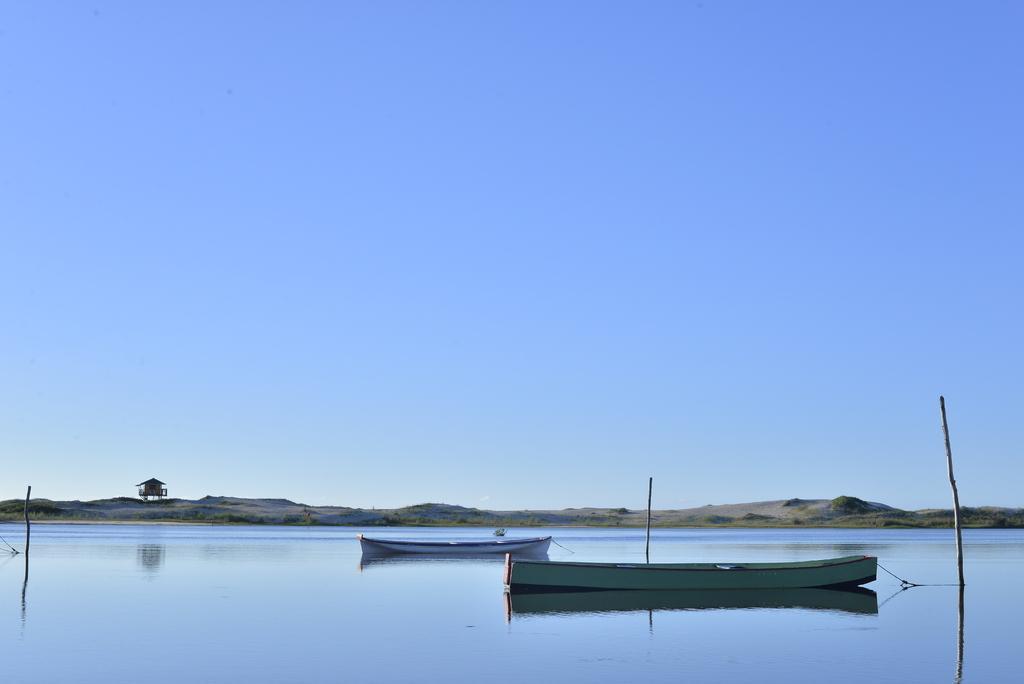Please provide a concise description of this image. In this picture we can see water at the bottom, there are two boats and three sticks in the middle, in the background we can see grass and a house, there is the sky at the top of the picture. 